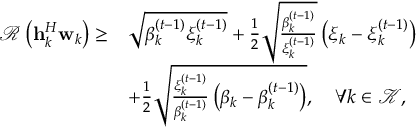<formula> <loc_0><loc_0><loc_500><loc_500>\begin{array} { r l } { \mathcal { R } \left ( { h } _ { k } ^ { H } w _ { k } \right ) \geq } & { \sqrt { \beta _ { k } ^ { ( t - 1 ) } \xi _ { k } ^ { ( t - 1 ) } } + \frac { 1 } { 2 } \sqrt { \frac { \beta _ { k } ^ { ( t - 1 ) } } { \xi _ { k } ^ { ( t - 1 ) } } } \left ( \xi _ { k } - \xi _ { k } ^ { ( t - 1 ) } \right ) } \\ & { + \frac { 1 } { 2 } \sqrt { \frac { \xi _ { k } ^ { ( t - 1 ) } } { \beta _ { k } ^ { ( t - 1 ) } } \left ( \beta _ { k } - \beta _ { k } ^ { ( t - 1 ) } \right ) } , \quad \forall k \in \mathcal { K } , } \end{array}</formula> 